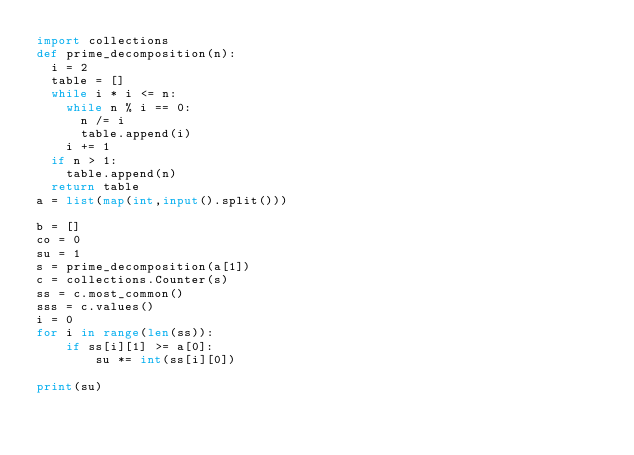<code> <loc_0><loc_0><loc_500><loc_500><_Python_>import collections
def prime_decomposition(n):
  i = 2
  table = []
  while i * i <= n:
    while n % i == 0:
      n /= i
      table.append(i)
    i += 1
  if n > 1:
    table.append(n)
  return table
a = list(map(int,input().split()))

b = []
co = 0
su = 1
s = prime_decomposition(a[1])
c = collections.Counter(s)
ss = c.most_common()
sss = c.values()
i = 0
for i in range(len(ss)):
    if ss[i][1] >= a[0]:
        su *= int(ss[i][0])

print(su)
</code> 